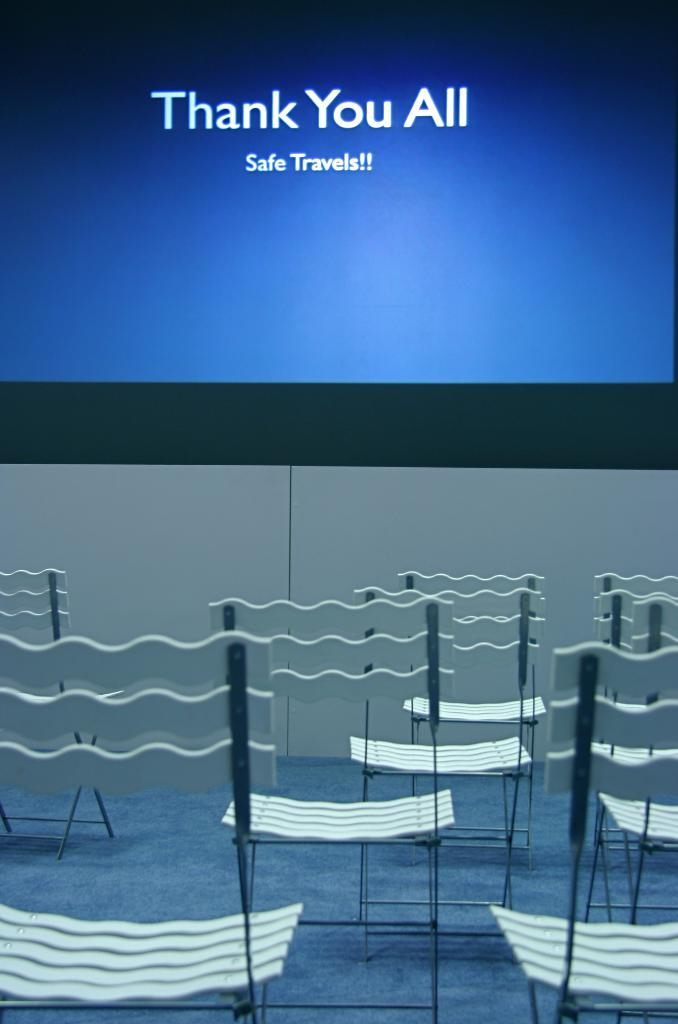What is displayed on the screen in the image? There is a screen with text in the image. What type of furniture is present in the image? There are chairs in the image. What is on the floor in the image? There is a floor mat in the image. What type of rod is used to stir the substance on the floor mat in the image? There is no rod or substance present on the floor mat in the image. Can you see a rabbit hopping on the chairs in the image? There is no rabbit present in the image. 